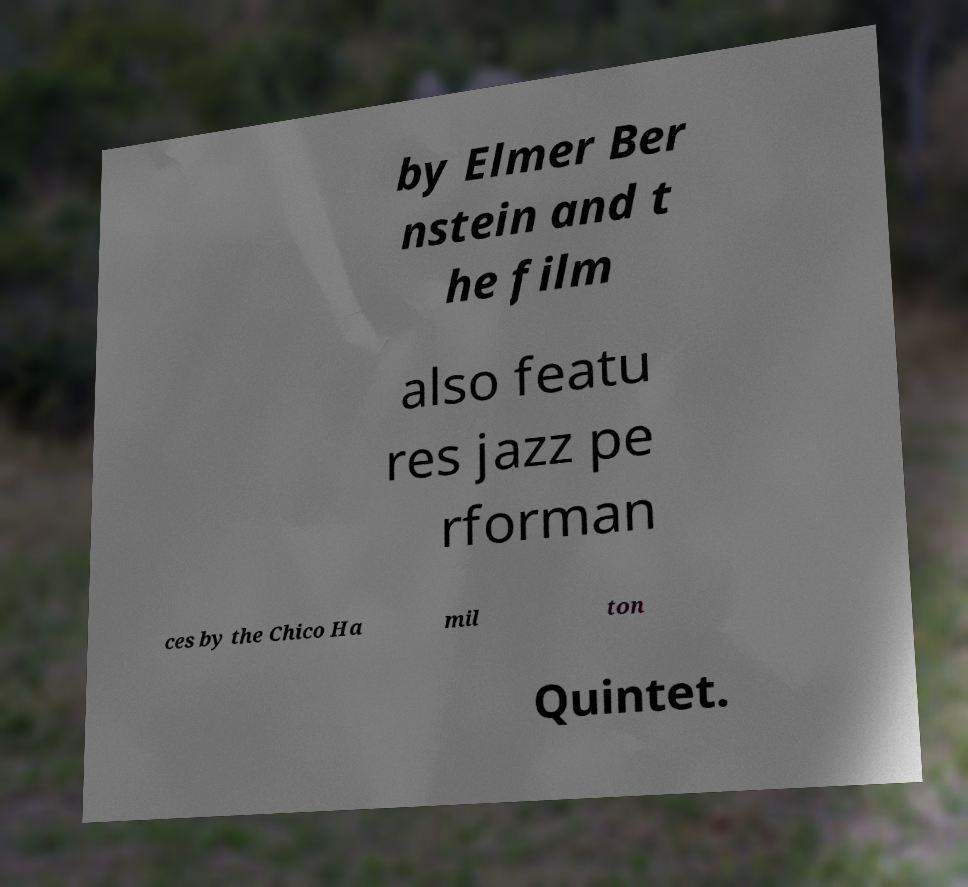Can you read and provide the text displayed in the image?This photo seems to have some interesting text. Can you extract and type it out for me? by Elmer Ber nstein and t he film also featu res jazz pe rforman ces by the Chico Ha mil ton Quintet. 